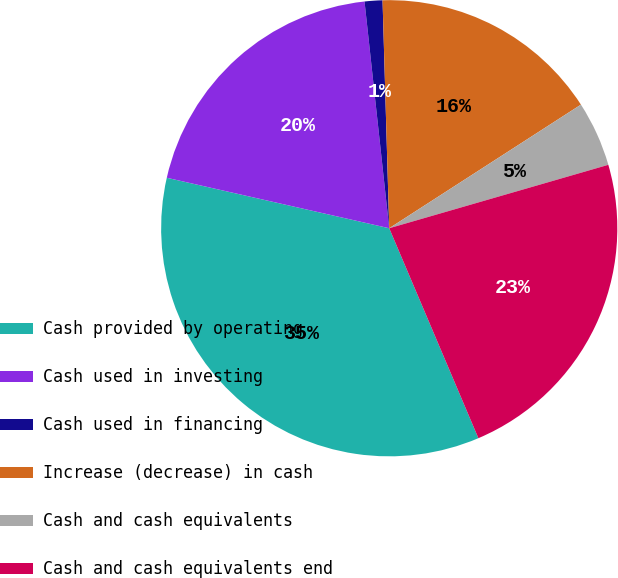<chart> <loc_0><loc_0><loc_500><loc_500><pie_chart><fcel>Cash provided by operating<fcel>Cash used in investing<fcel>Cash used in financing<fcel>Increase (decrease) in cash<fcel>Cash and cash equivalents<fcel>Cash and cash equivalents end<nl><fcel>34.94%<fcel>19.72%<fcel>1.26%<fcel>16.35%<fcel>4.63%<fcel>23.09%<nl></chart> 